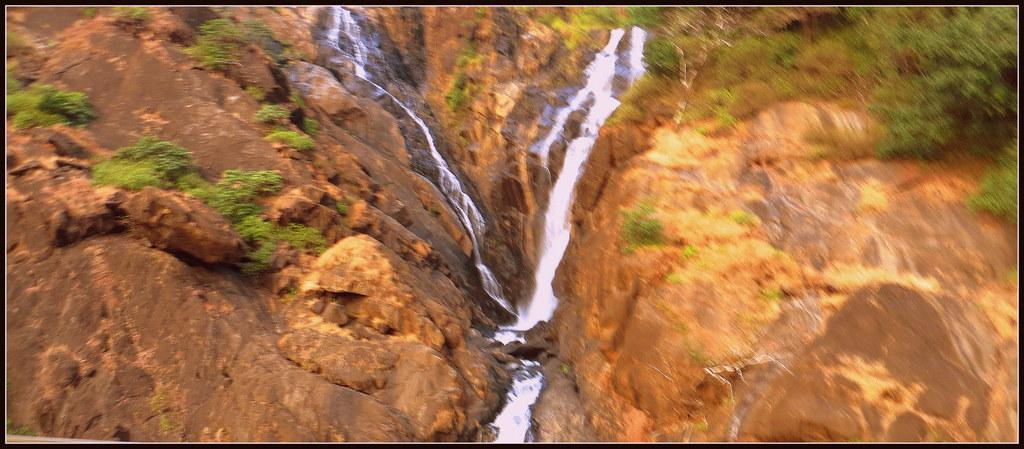What type of natural features can be seen in the image? There are rocks, waterfalls, and plants in the image. Can you describe the rocks in the image? The rocks are visible in the image, but no specific details about their size, shape, or color are provided. What is the source of the water in the image? The waterfalls in the image indicate that there is a source of water, likely a river or stream. What type of vegetation is present in the image? Plants are visible in the image, but no specific details about their type or size are provided. How many socks are visible in the image? There are no socks present in the image. What is the cause of death depicted in the image? There is no depiction of death in the image; it features rocks, waterfalls, and plants. 